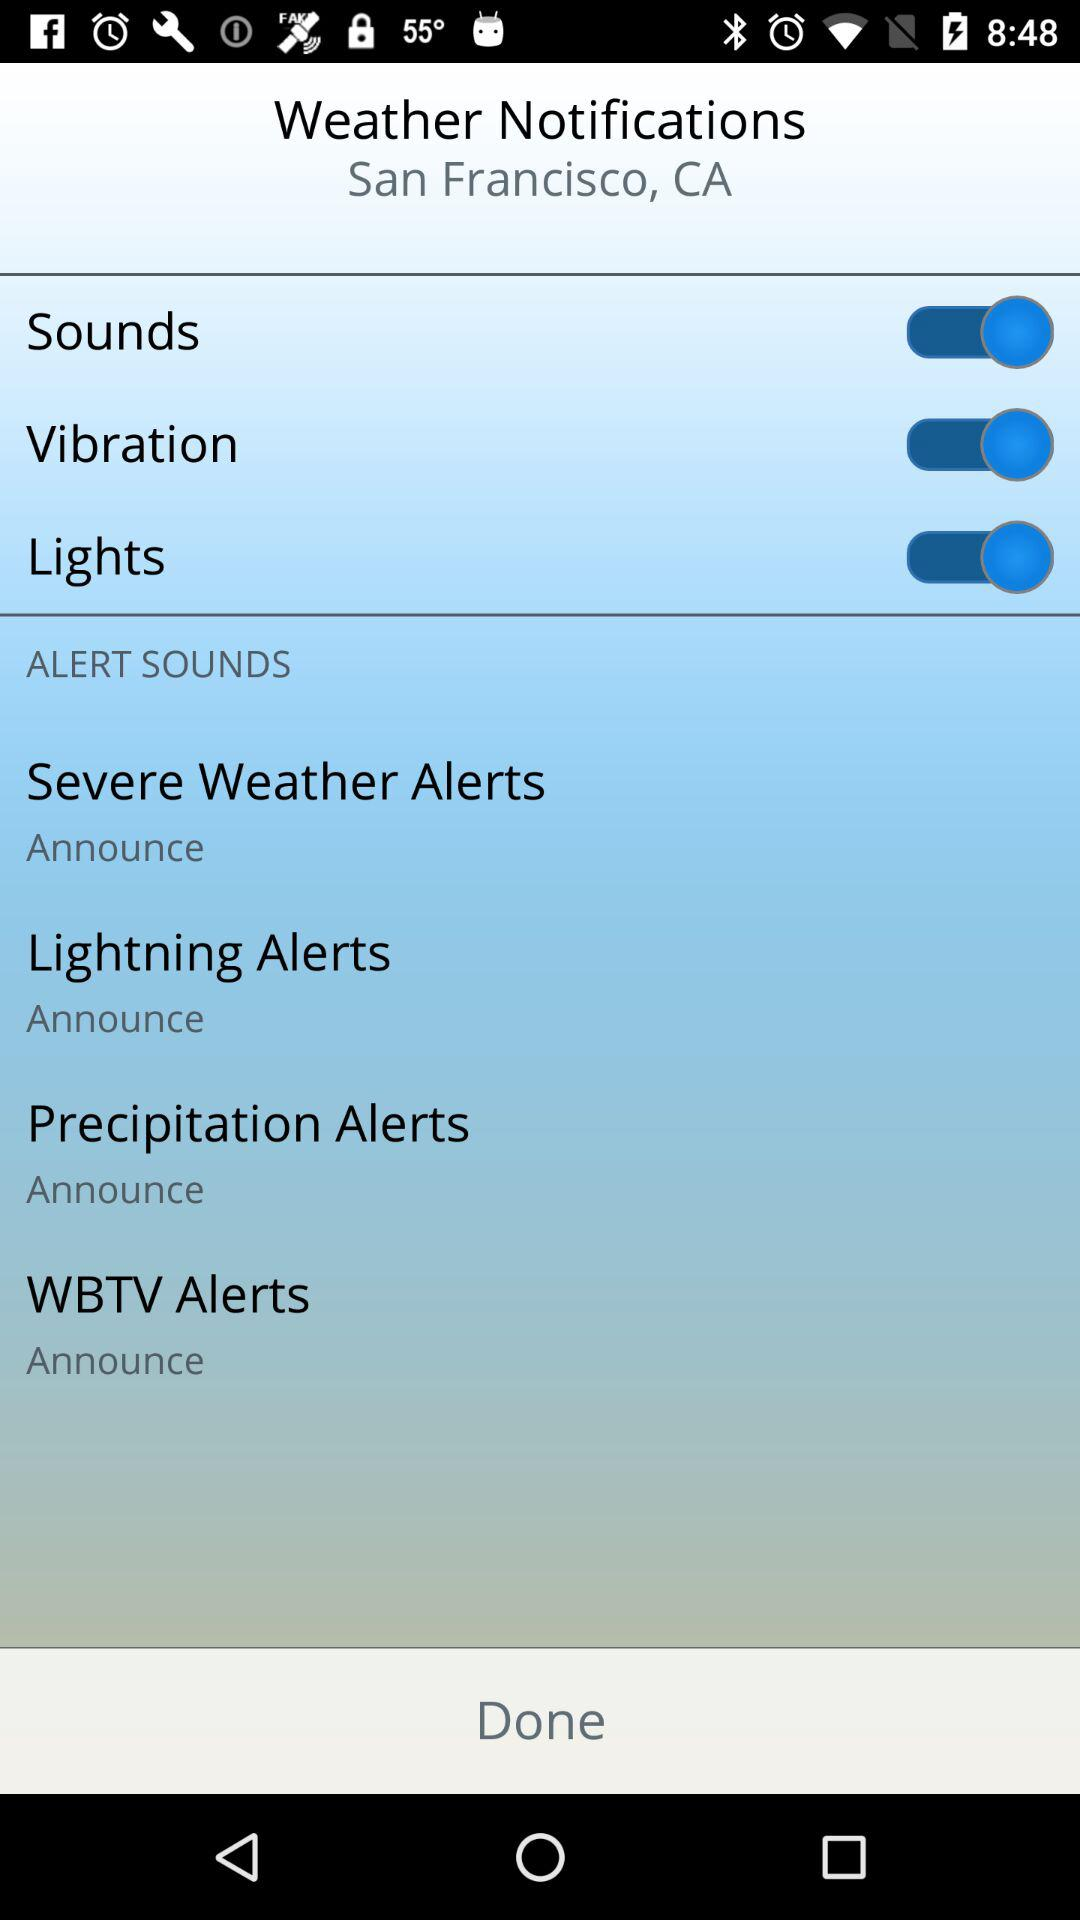What is the location? The location is San Francisco, CA. 